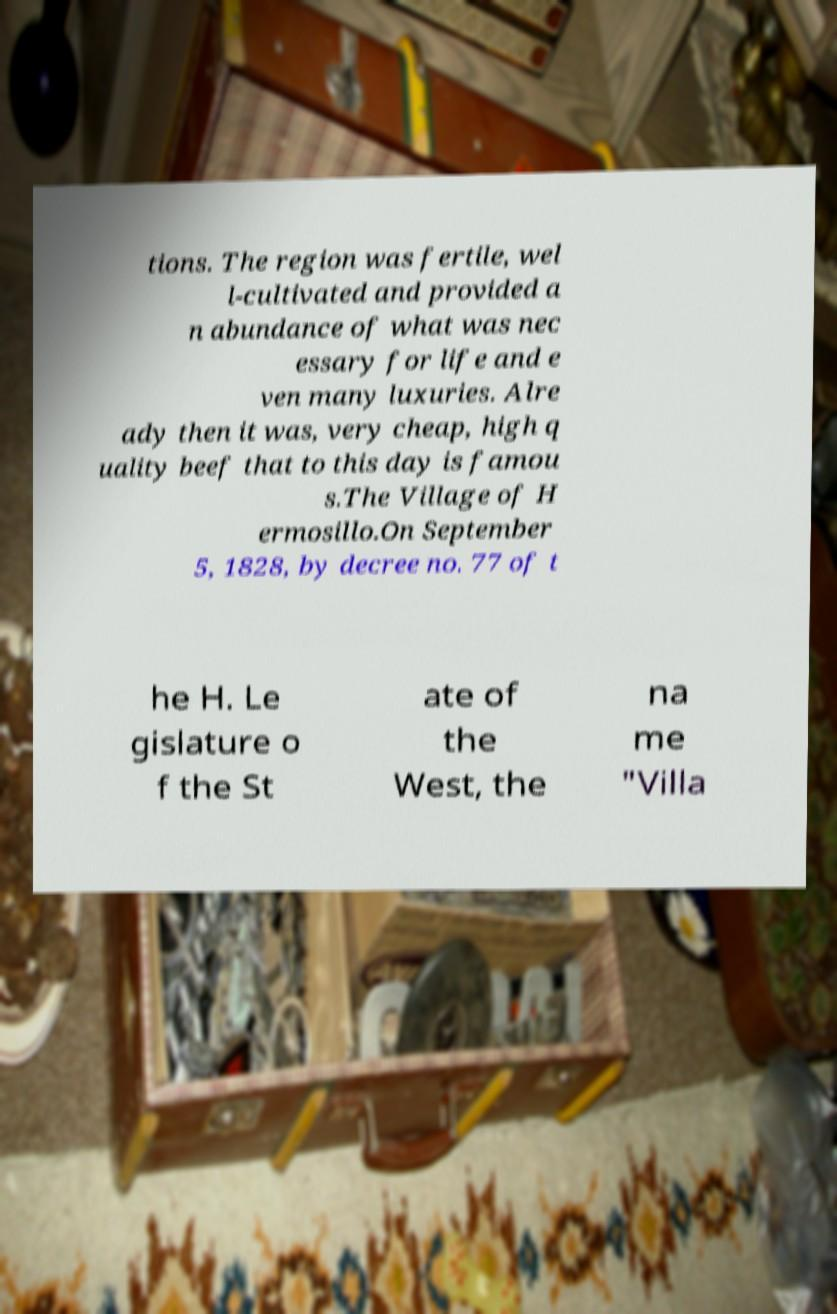I need the written content from this picture converted into text. Can you do that? tions. The region was fertile, wel l-cultivated and provided a n abundance of what was nec essary for life and e ven many luxuries. Alre ady then it was, very cheap, high q uality beef that to this day is famou s.The Village of H ermosillo.On September 5, 1828, by decree no. 77 of t he H. Le gislature o f the St ate of the West, the na me "Villa 